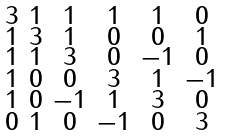Convert formula to latex. <formula><loc_0><loc_0><loc_500><loc_500>\begin{smallmatrix} 3 & 1 & 1 & 1 & 1 & 0 \\ 1 & 3 & 1 & 0 & 0 & 1 \\ 1 & 1 & 3 & 0 & - 1 & 0 \\ 1 & 0 & 0 & 3 & 1 & - 1 \\ 1 & 0 & - 1 & 1 & 3 & 0 \\ 0 & 1 & 0 & - 1 & 0 & 3 \end{smallmatrix}</formula> 